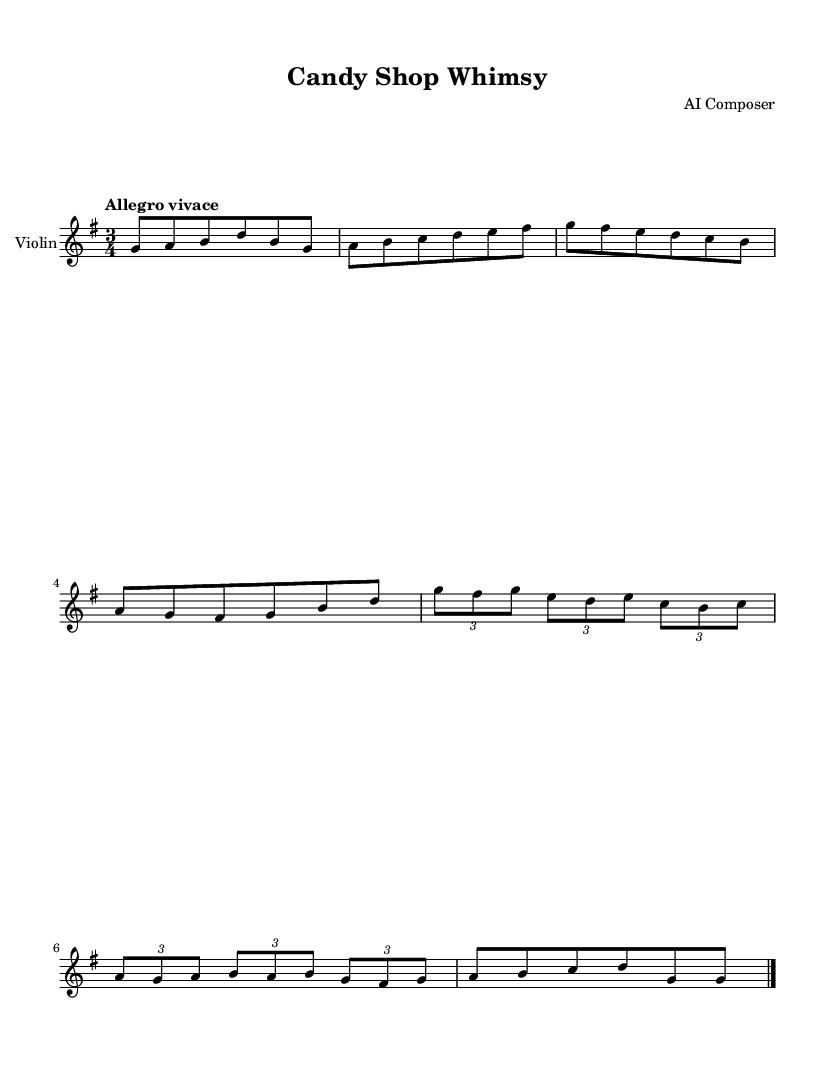What is the key signature of this music? The key signature is G major, which has one sharp (F#). This can be identified by looking at the key signature at the beginning of the staff.
Answer: G major What is the time signature of this music? The time signature is 3/4, which can be found at the beginning of the sheet music where it specifies how many beats per measure and what note value receives one beat.
Answer: 3/4 What is the tempo marking for this piece? The tempo marking is "Allegro vivace," which indicates that the music should be played quickly and cheerfully. This is stated directly in the tempo indication at the top of the music.
Answer: Allegro vivace How many measures are there in the music? There are 8 measures in total, which can be counted by looking at the bars that separate the music segments. Each bar indicates a measure, and the music ends with a final bar line.
Answer: 8 What is the last note in the music? The last note in the music is a G, which can be located at the end of the staff music where the final note is placed.
Answer: G Identify the rhythmic grouping used in measures 5 and 6. Measures 5 and 6 each contain tuplets, specifically a triplet grouping. The notation system uses brackets to indicate these groupings, which involve three notes played in the duration where normally two would be played.
Answer: Triplet 